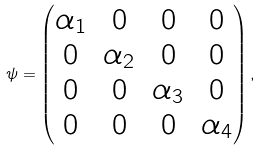Convert formula to latex. <formula><loc_0><loc_0><loc_500><loc_500>\psi = \begin{pmatrix} \alpha _ { 1 } & 0 & 0 & 0 \\ 0 & \alpha _ { 2 } & 0 & 0 \\ 0 & 0 & \alpha _ { 3 } & 0 \\ 0 & 0 & 0 & \alpha _ { 4 } \end{pmatrix} ,</formula> 